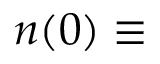<formula> <loc_0><loc_0><loc_500><loc_500>n ( 0 ) \equiv</formula> 